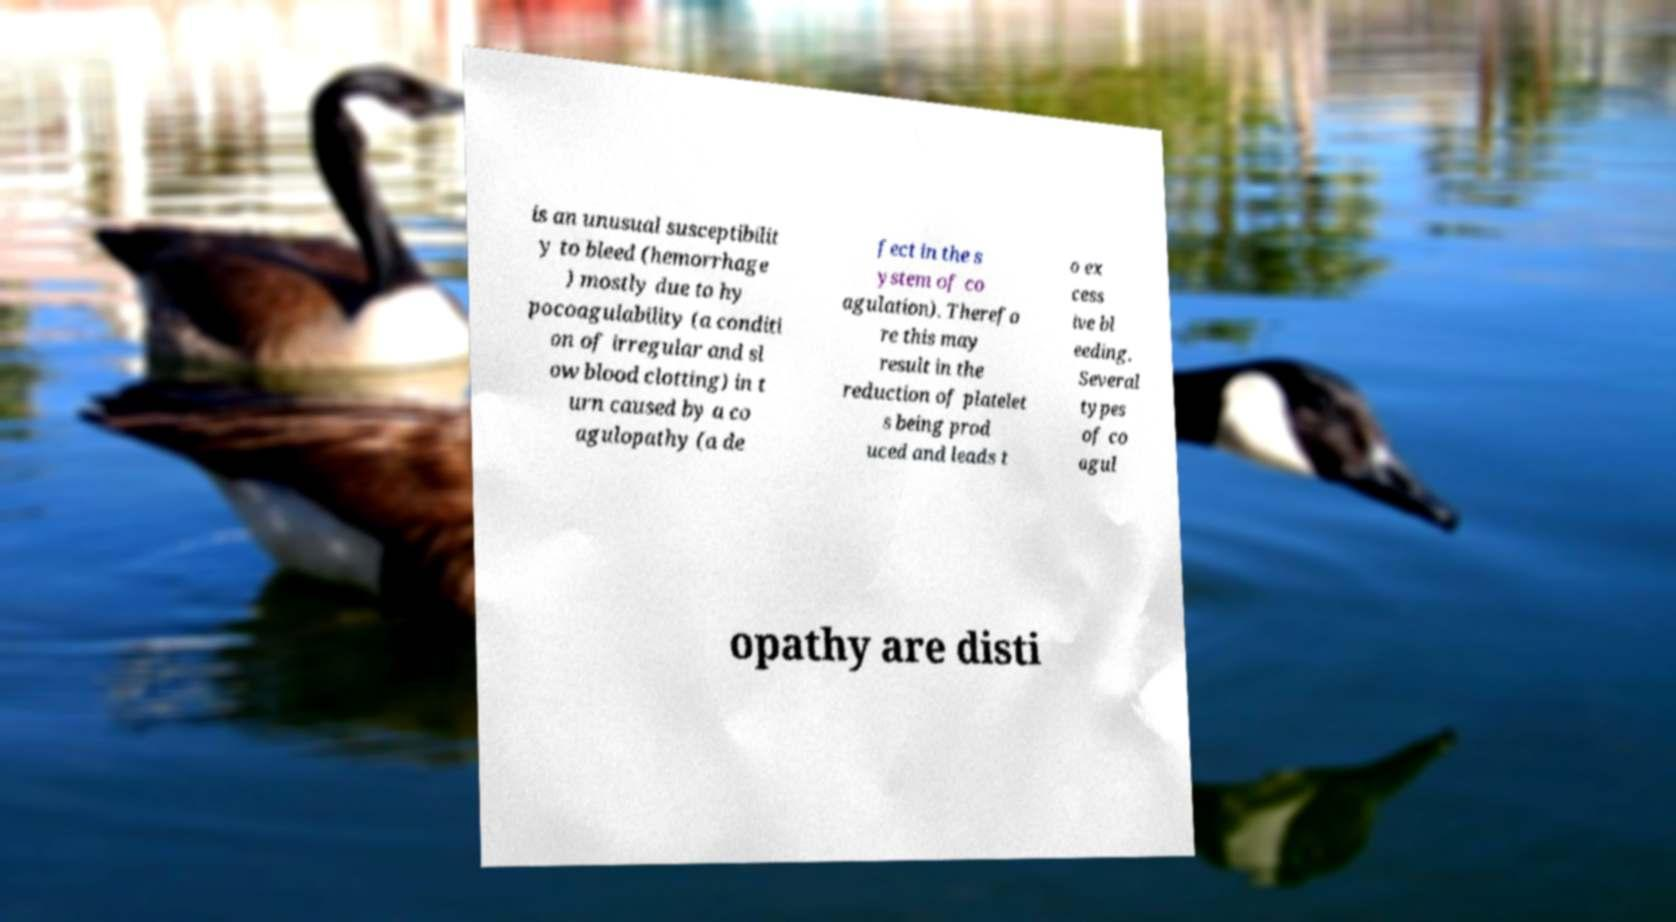Could you assist in decoding the text presented in this image and type it out clearly? is an unusual susceptibilit y to bleed (hemorrhage ) mostly due to hy pocoagulability (a conditi on of irregular and sl ow blood clotting) in t urn caused by a co agulopathy (a de fect in the s ystem of co agulation). Therefo re this may result in the reduction of platelet s being prod uced and leads t o ex cess ive bl eeding. Several types of co agul opathy are disti 